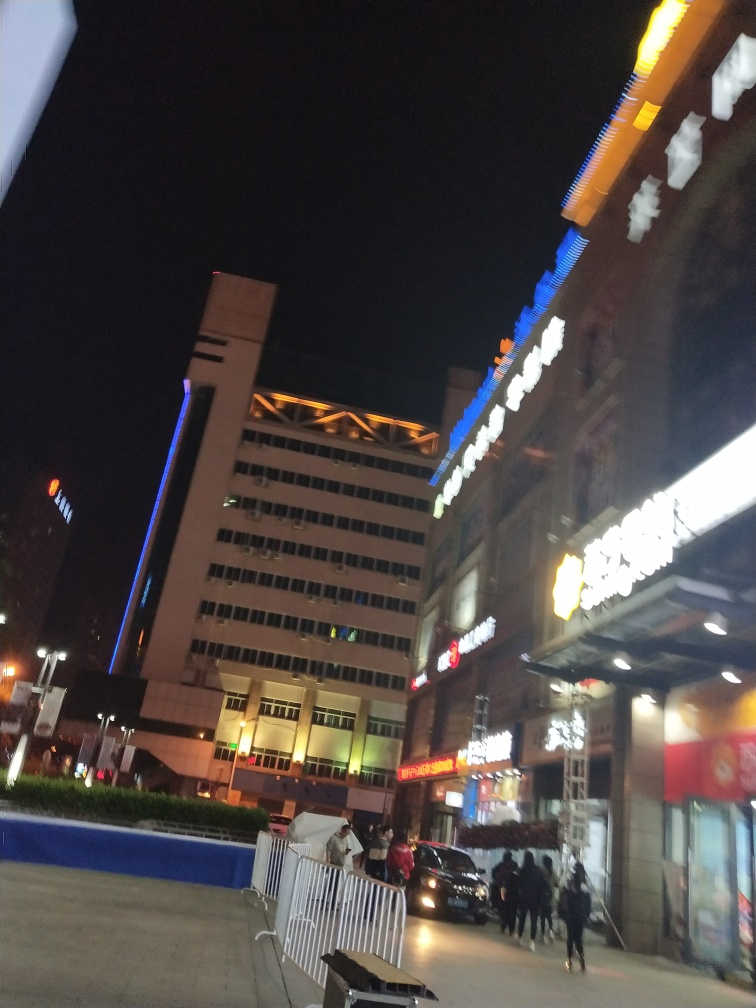What time of day does this photo appear to be taken? The photo seems to be taken at night, as evidenced by the dark sky and the artificial lighting from the building's signage and street lights illuminating the scene. 